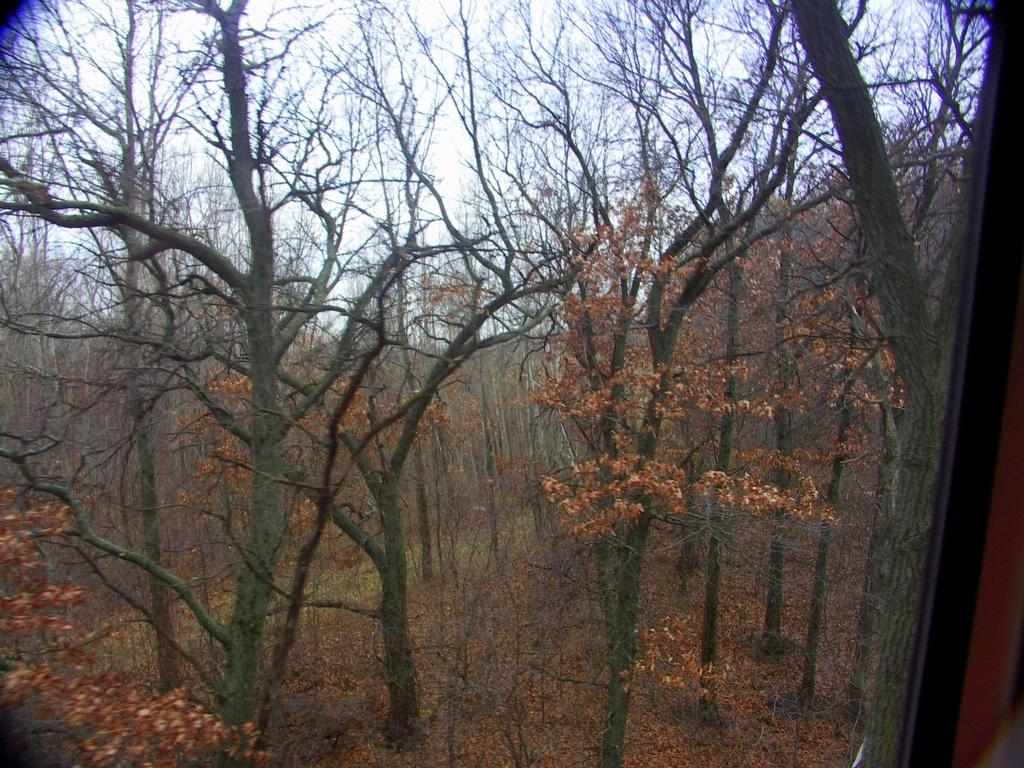Where was the image taken? The image was taken outdoors. What can be seen in the image besides the sky? There are many trees in the image. What is visible at the top of the image? The sky is visible at the top of the image. How much salt is visible on the ground in the image? There is no salt visible on the ground in the image. Is there a crate present in the image? There is no crate present in the image. 